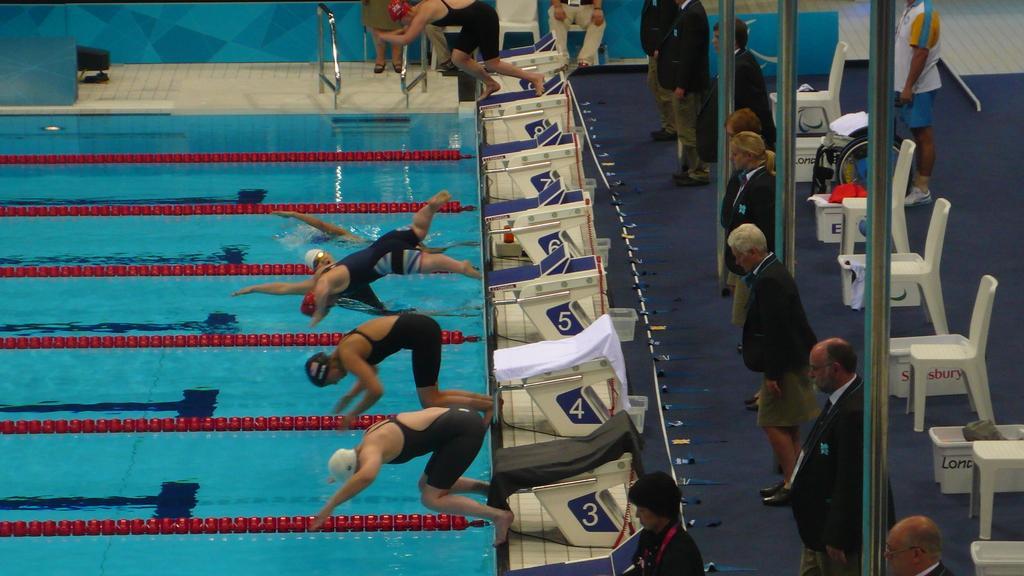In one or two sentences, can you explain what this image depicts? In this image, there are three persons jumping into the pool. There are some persons in the middle of the image standing and wearing clothes. There are some chairs on the right side of the image. 